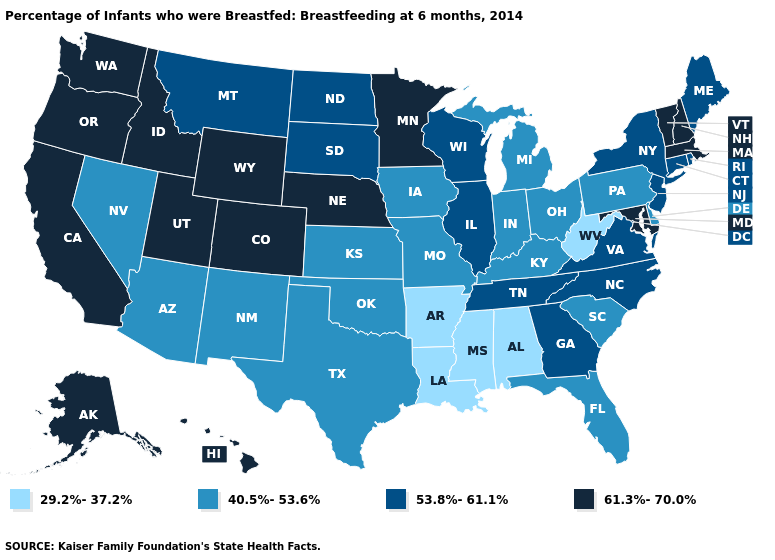What is the lowest value in the USA?
Write a very short answer. 29.2%-37.2%. Which states have the lowest value in the South?
Concise answer only. Alabama, Arkansas, Louisiana, Mississippi, West Virginia. Which states have the lowest value in the Northeast?
Answer briefly. Pennsylvania. Is the legend a continuous bar?
Concise answer only. No. Name the states that have a value in the range 61.3%-70.0%?
Write a very short answer. Alaska, California, Colorado, Hawaii, Idaho, Maryland, Massachusetts, Minnesota, Nebraska, New Hampshire, Oregon, Utah, Vermont, Washington, Wyoming. Does West Virginia have the lowest value in the USA?
Be succinct. Yes. Is the legend a continuous bar?
Concise answer only. No. Does West Virginia have the lowest value in the USA?
Be succinct. Yes. What is the value of Massachusetts?
Write a very short answer. 61.3%-70.0%. Among the states that border Minnesota , does North Dakota have the highest value?
Keep it brief. Yes. Name the states that have a value in the range 53.8%-61.1%?
Short answer required. Connecticut, Georgia, Illinois, Maine, Montana, New Jersey, New York, North Carolina, North Dakota, Rhode Island, South Dakota, Tennessee, Virginia, Wisconsin. Does Tennessee have the same value as Connecticut?
Keep it brief. Yes. How many symbols are there in the legend?
Be succinct. 4. What is the value of Utah?
Be succinct. 61.3%-70.0%. 